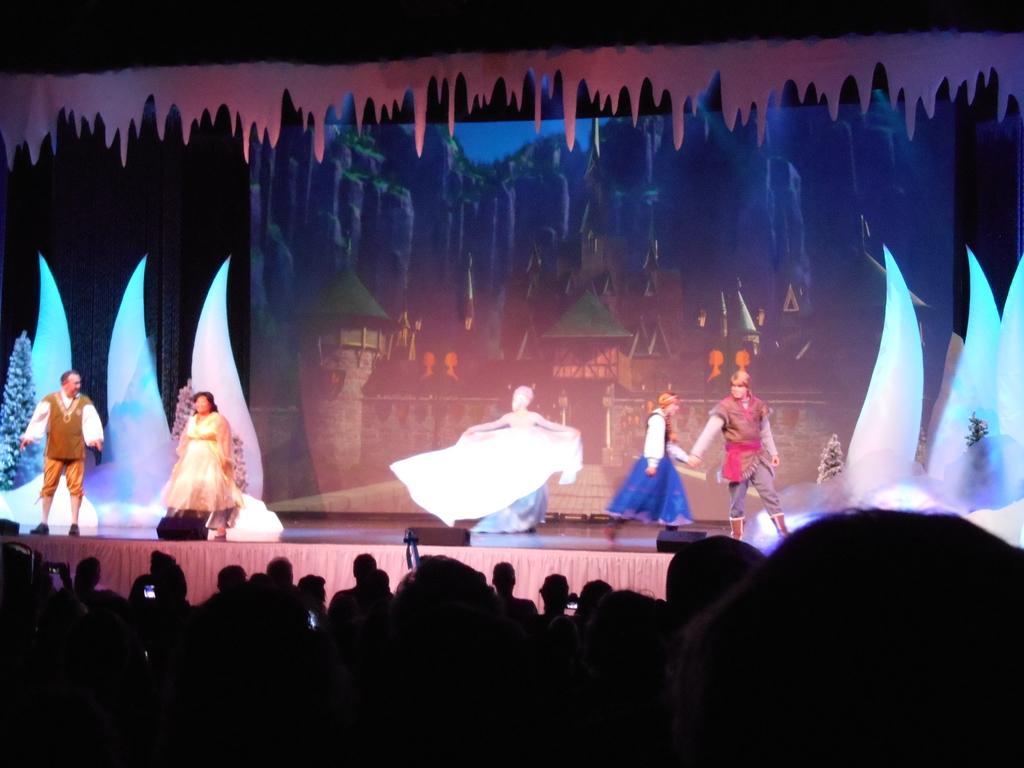Can you describe this image briefly? In the foreground we can see people. In the center of the picture there is a stage, on the stage we can see people performing. In the background there are some decorations like trees and other objects. In the center of the background it is looking like a screen. At the top there is a design of decorative item. 